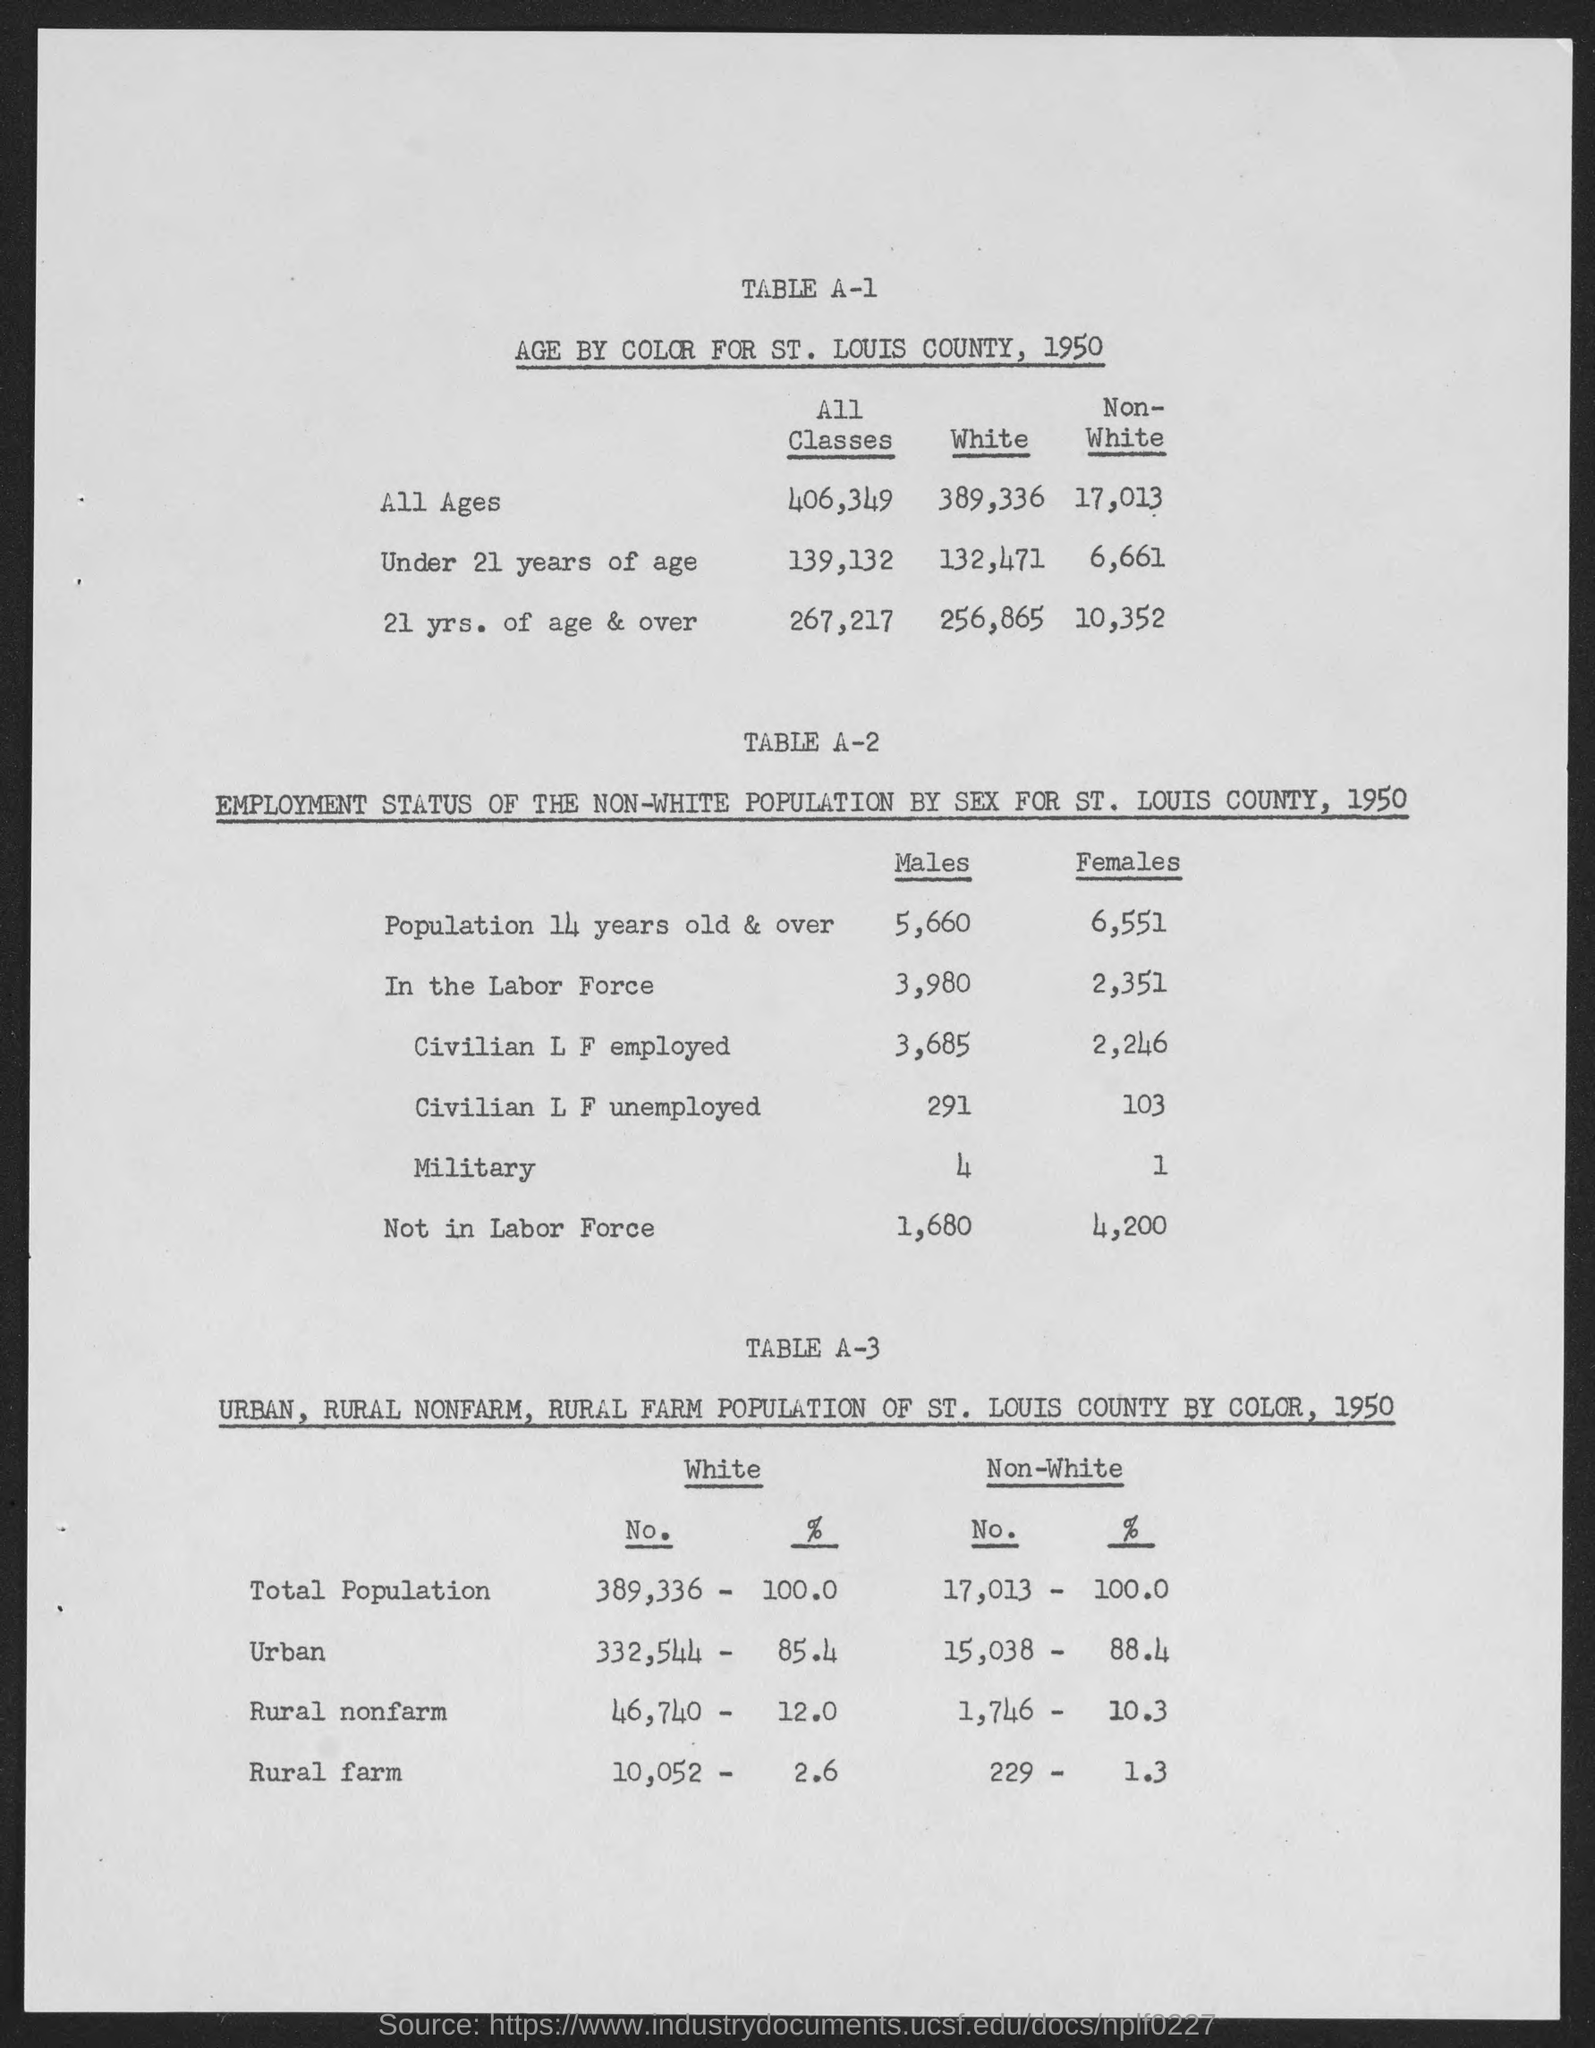What is the age by color for St. Louis county, 1950 for all ages for white? In 1950, the population of white individuals of all ages in St. Louis County was 389,336, as depicted in the statistical data provided in the image. 